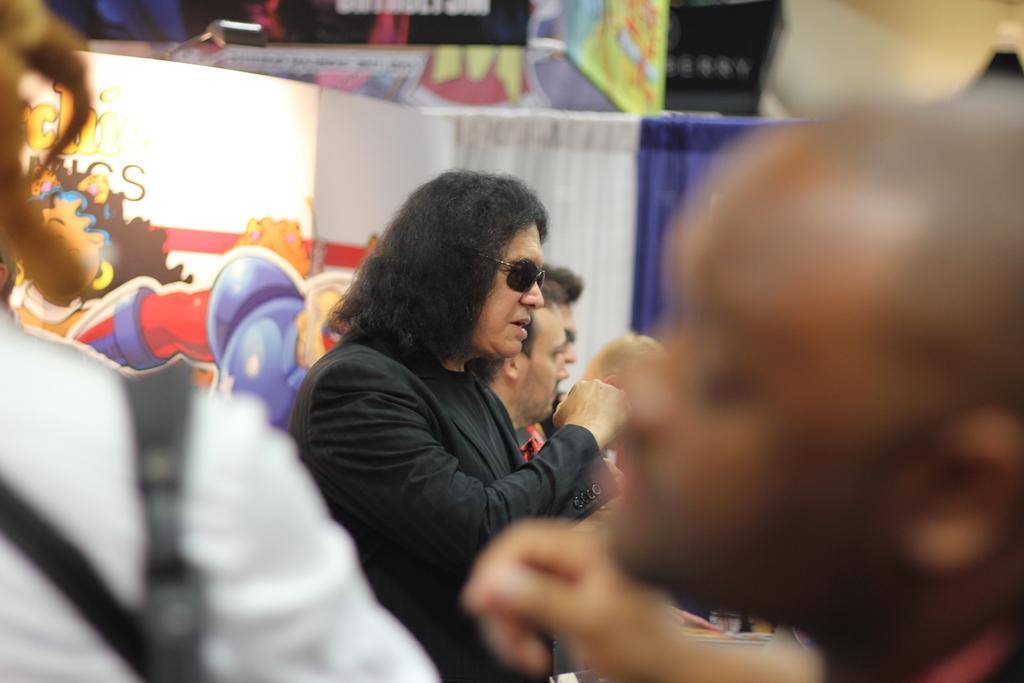Can you describe this image briefly? This picture describes about group of people, on the middle of the given image we can see a man, he wore spectacles, in the background we can see curtains and paintings on the Wall. 